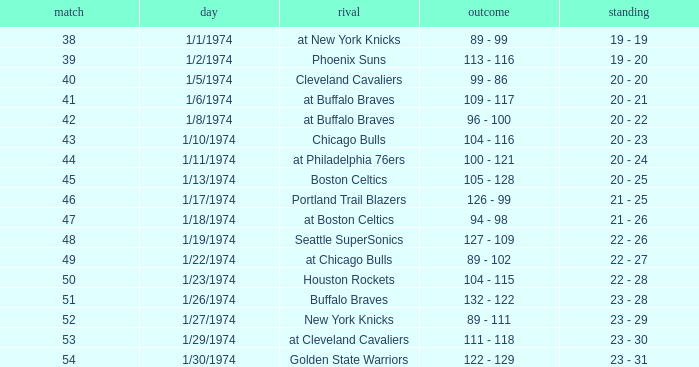What opponent played on 1/13/1974? Boston Celtics. 